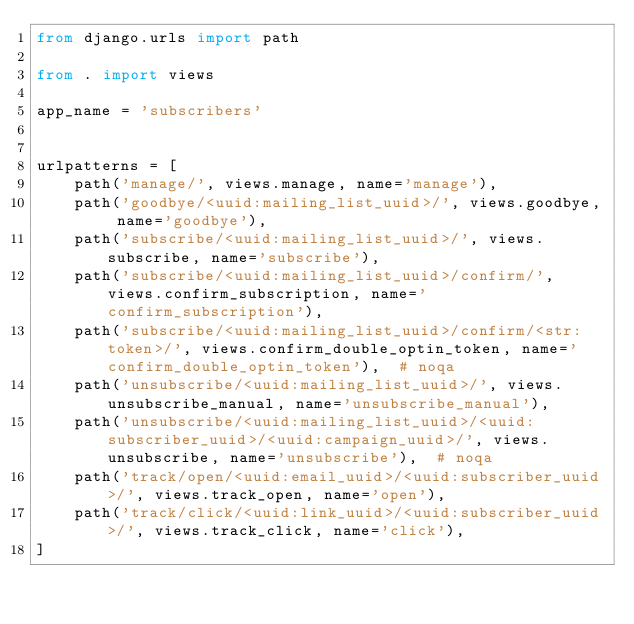<code> <loc_0><loc_0><loc_500><loc_500><_Python_>from django.urls import path

from . import views

app_name = 'subscribers'


urlpatterns = [
    path('manage/', views.manage, name='manage'),
    path('goodbye/<uuid:mailing_list_uuid>/', views.goodbye, name='goodbye'),
    path('subscribe/<uuid:mailing_list_uuid>/', views.subscribe, name='subscribe'),
    path('subscribe/<uuid:mailing_list_uuid>/confirm/', views.confirm_subscription, name='confirm_subscription'),
    path('subscribe/<uuid:mailing_list_uuid>/confirm/<str:token>/', views.confirm_double_optin_token, name='confirm_double_optin_token'),  # noqa
    path('unsubscribe/<uuid:mailing_list_uuid>/', views.unsubscribe_manual, name='unsubscribe_manual'),
    path('unsubscribe/<uuid:mailing_list_uuid>/<uuid:subscriber_uuid>/<uuid:campaign_uuid>/', views.unsubscribe, name='unsubscribe'),  # noqa
    path('track/open/<uuid:email_uuid>/<uuid:subscriber_uuid>/', views.track_open, name='open'),
    path('track/click/<uuid:link_uuid>/<uuid:subscriber_uuid>/', views.track_click, name='click'),
]
</code> 